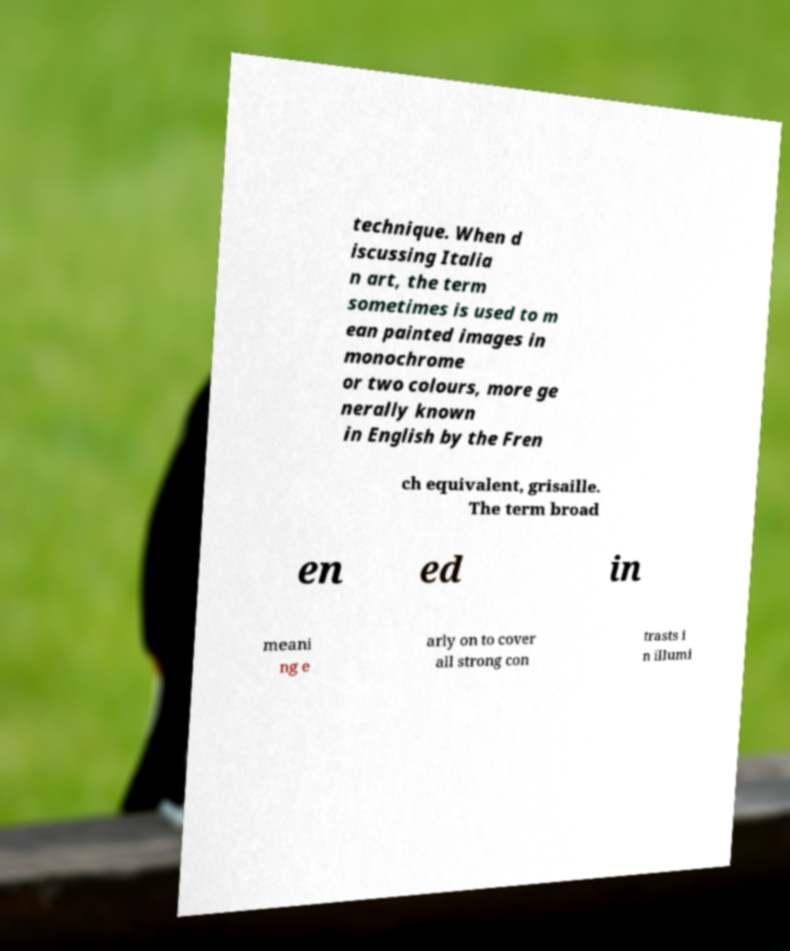Can you read and provide the text displayed in the image?This photo seems to have some interesting text. Can you extract and type it out for me? technique. When d iscussing Italia n art, the term sometimes is used to m ean painted images in monochrome or two colours, more ge nerally known in English by the Fren ch equivalent, grisaille. The term broad en ed in meani ng e arly on to cover all strong con trasts i n illumi 